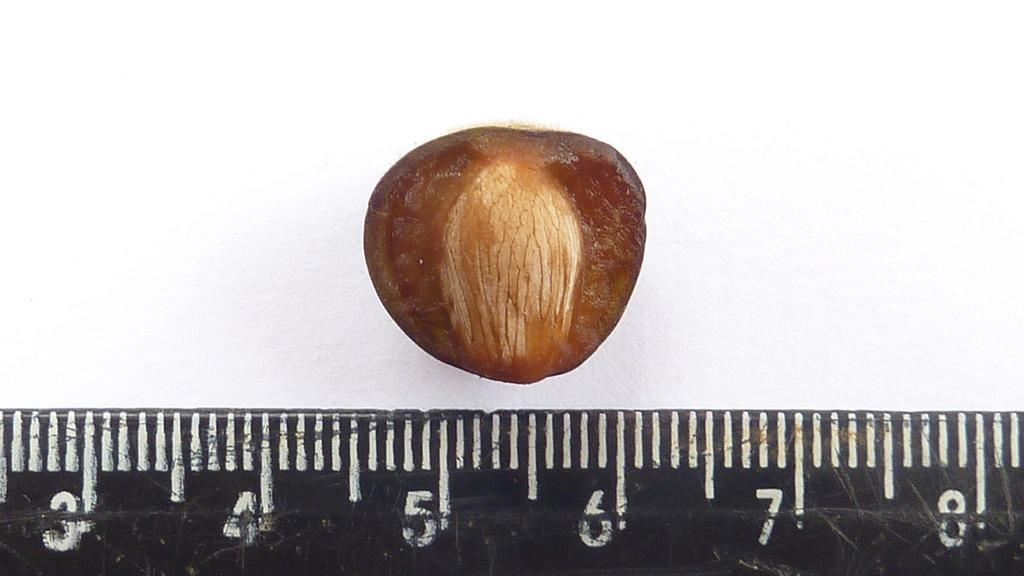<image>
Relay a brief, clear account of the picture shown. A nut is next to a ruler measuring between 4.5 and 6.4. 